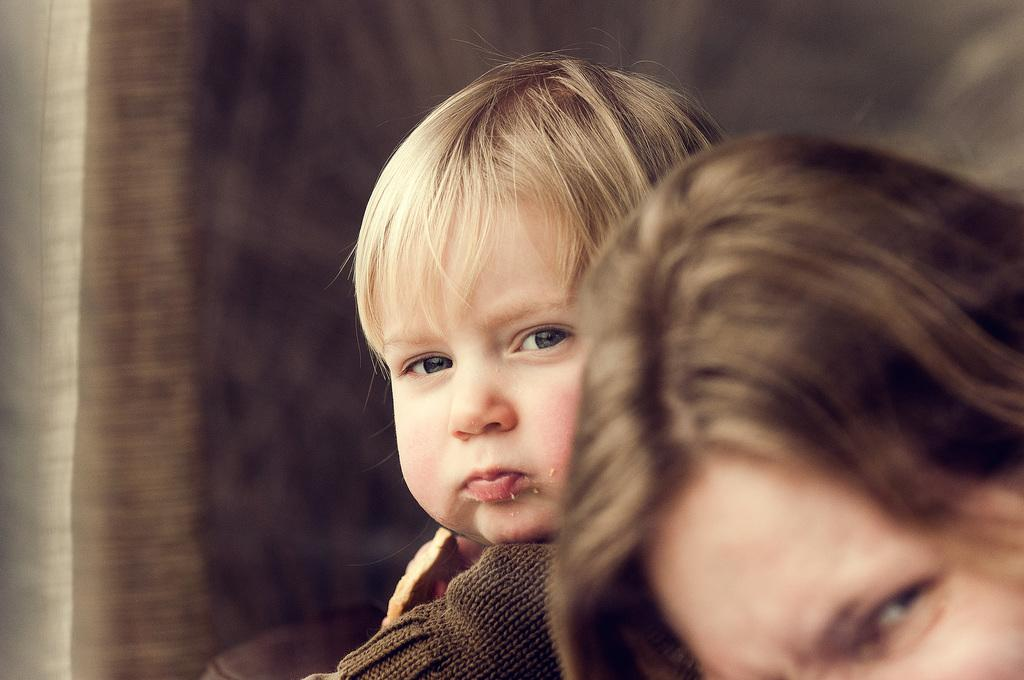How many people are in the image? There are two persons in the image. Can you describe the background of the image? The background of the image is blurred. Is there a lake visible in the image? There is no mention of a lake in the provided facts, and therefore it cannot be determined if a lake is present in the image. 